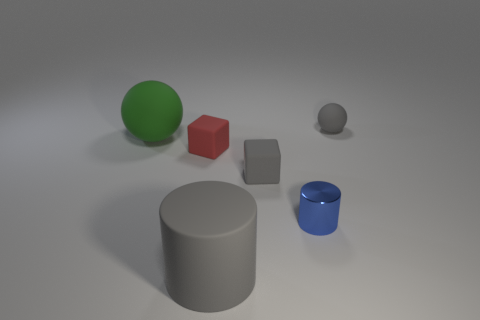Are there any other things that have the same size as the blue cylinder?
Make the answer very short. Yes. What number of large objects are blue objects or brown rubber blocks?
Ensure brevity in your answer.  0. The other matte object that is the same shape as the green object is what size?
Offer a very short reply. Small. The small blue thing has what shape?
Make the answer very short. Cylinder. Is the material of the big cylinder the same as the large thing behind the metallic object?
Provide a short and direct response. Yes. What number of rubber objects are gray blocks or big cylinders?
Ensure brevity in your answer.  2. There is a matte ball on the left side of the red object; what is its size?
Keep it short and to the point. Large. There is another sphere that is the same material as the small sphere; what size is it?
Provide a succinct answer. Large. What number of rubber things have the same color as the small rubber ball?
Ensure brevity in your answer.  2. Are any green rubber cubes visible?
Make the answer very short. No. 